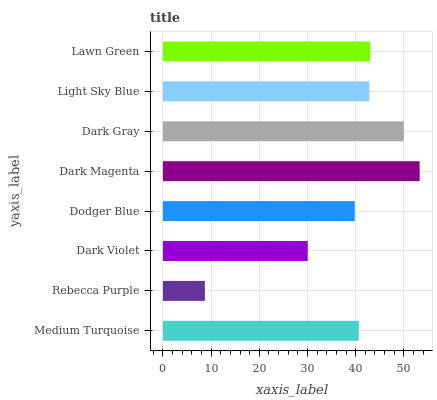Is Rebecca Purple the minimum?
Answer yes or no. Yes. Is Dark Magenta the maximum?
Answer yes or no. Yes. Is Dark Violet the minimum?
Answer yes or no. No. Is Dark Violet the maximum?
Answer yes or no. No. Is Dark Violet greater than Rebecca Purple?
Answer yes or no. Yes. Is Rebecca Purple less than Dark Violet?
Answer yes or no. Yes. Is Rebecca Purple greater than Dark Violet?
Answer yes or no. No. Is Dark Violet less than Rebecca Purple?
Answer yes or no. No. Is Light Sky Blue the high median?
Answer yes or no. Yes. Is Medium Turquoise the low median?
Answer yes or no. Yes. Is Dark Violet the high median?
Answer yes or no. No. Is Dark Violet the low median?
Answer yes or no. No. 